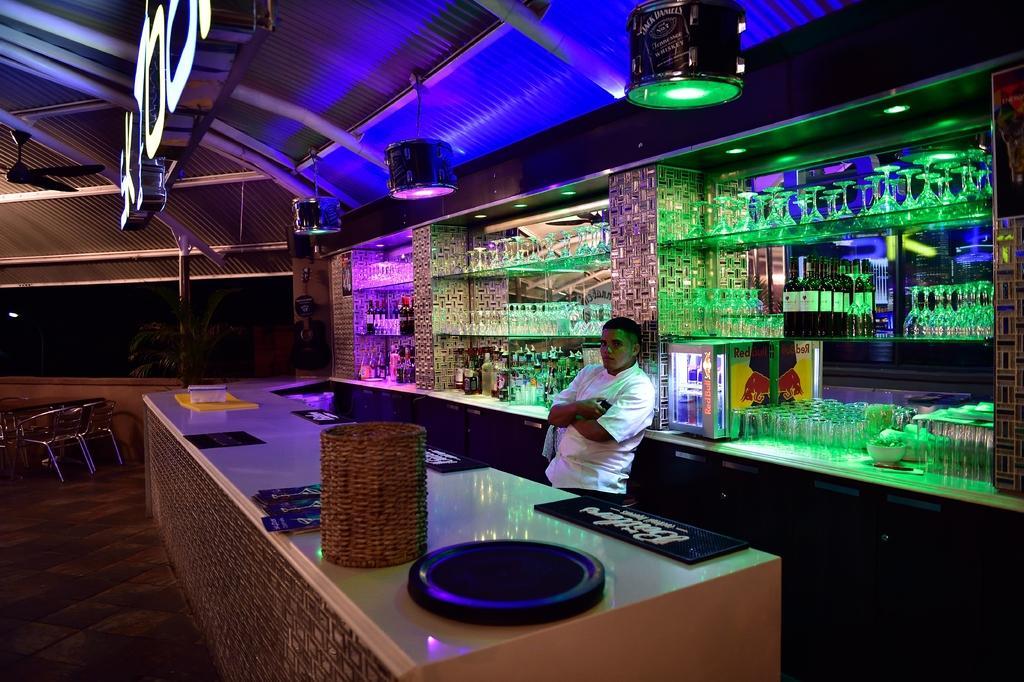Please provide a concise description of this image. In the center of the image we can see a man standing. He is wearing a white shirt, before him we can see a counter table and there are things placed on the counter table. In the background there is a shelf and we can see wine bottles and glasses placed in the shelf. On the left there are chairs. In the background there is a tree. 